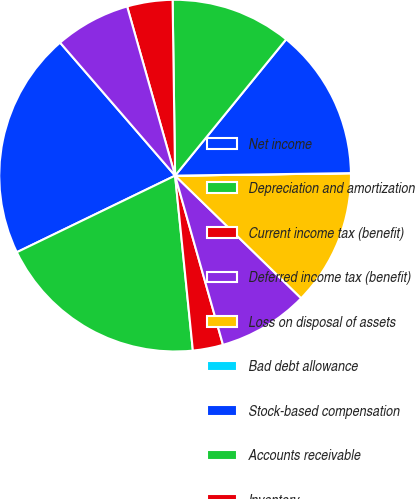Convert chart. <chart><loc_0><loc_0><loc_500><loc_500><pie_chart><fcel>Net income<fcel>Depreciation and amortization<fcel>Current income tax (benefit)<fcel>Deferred income tax (benefit)<fcel>Loss on disposal of assets<fcel>Bad debt allowance<fcel>Stock-based compensation<fcel>Accounts receivable<fcel>Inventory<fcel>Prepaid expenses<nl><fcel>20.83%<fcel>19.44%<fcel>2.78%<fcel>8.33%<fcel>12.5%<fcel>0.01%<fcel>13.89%<fcel>11.11%<fcel>4.17%<fcel>6.95%<nl></chart> 